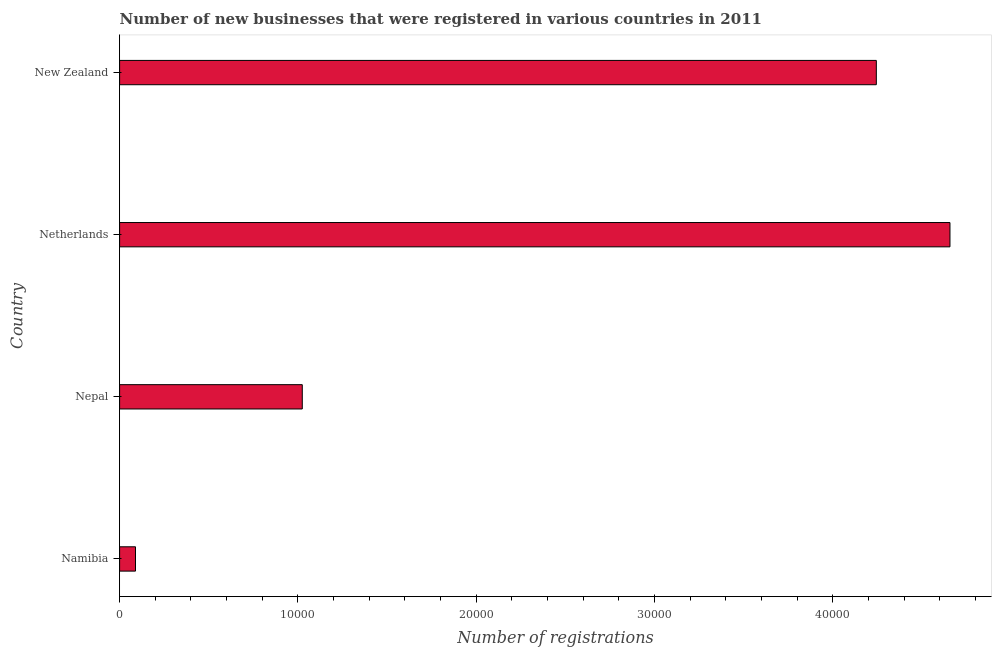Does the graph contain any zero values?
Your answer should be compact. No. Does the graph contain grids?
Provide a succinct answer. No. What is the title of the graph?
Keep it short and to the point. Number of new businesses that were registered in various countries in 2011. What is the label or title of the X-axis?
Your response must be concise. Number of registrations. What is the label or title of the Y-axis?
Your answer should be compact. Country. What is the number of new business registrations in Namibia?
Your answer should be very brief. 892. Across all countries, what is the maximum number of new business registrations?
Ensure brevity in your answer.  4.66e+04. Across all countries, what is the minimum number of new business registrations?
Offer a very short reply. 892. In which country was the number of new business registrations maximum?
Keep it short and to the point. Netherlands. In which country was the number of new business registrations minimum?
Offer a terse response. Namibia. What is the sum of the number of new business registrations?
Keep it short and to the point. 1.00e+05. What is the difference between the number of new business registrations in Namibia and Nepal?
Offer a terse response. -9355. What is the average number of new business registrations per country?
Your answer should be compact. 2.50e+04. What is the median number of new business registrations?
Your response must be concise. 2.63e+04. What is the ratio of the number of new business registrations in Nepal to that in New Zealand?
Ensure brevity in your answer.  0.24. What is the difference between the highest and the second highest number of new business registrations?
Offer a very short reply. 4131. Is the sum of the number of new business registrations in Namibia and Nepal greater than the maximum number of new business registrations across all countries?
Your answer should be very brief. No. What is the difference between the highest and the lowest number of new business registrations?
Provide a succinct answer. 4.57e+04. How many bars are there?
Your answer should be very brief. 4. Are all the bars in the graph horizontal?
Offer a very short reply. Yes. What is the Number of registrations in Namibia?
Provide a succinct answer. 892. What is the Number of registrations in Nepal?
Your answer should be compact. 1.02e+04. What is the Number of registrations of Netherlands?
Make the answer very short. 4.66e+04. What is the Number of registrations of New Zealand?
Your answer should be very brief. 4.24e+04. What is the difference between the Number of registrations in Namibia and Nepal?
Your answer should be very brief. -9355. What is the difference between the Number of registrations in Namibia and Netherlands?
Provide a short and direct response. -4.57e+04. What is the difference between the Number of registrations in Namibia and New Zealand?
Keep it short and to the point. -4.16e+04. What is the difference between the Number of registrations in Nepal and Netherlands?
Your answer should be very brief. -3.63e+04. What is the difference between the Number of registrations in Nepal and New Zealand?
Your response must be concise. -3.22e+04. What is the difference between the Number of registrations in Netherlands and New Zealand?
Your answer should be very brief. 4131. What is the ratio of the Number of registrations in Namibia to that in Nepal?
Provide a succinct answer. 0.09. What is the ratio of the Number of registrations in Namibia to that in Netherlands?
Provide a short and direct response. 0.02. What is the ratio of the Number of registrations in Namibia to that in New Zealand?
Your response must be concise. 0.02. What is the ratio of the Number of registrations in Nepal to that in Netherlands?
Your answer should be compact. 0.22. What is the ratio of the Number of registrations in Nepal to that in New Zealand?
Give a very brief answer. 0.24. What is the ratio of the Number of registrations in Netherlands to that in New Zealand?
Provide a short and direct response. 1.1. 